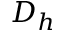Convert formula to latex. <formula><loc_0><loc_0><loc_500><loc_500>D _ { h }</formula> 